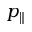Convert formula to latex. <formula><loc_0><loc_0><loc_500><loc_500>p _ { \| }</formula> 